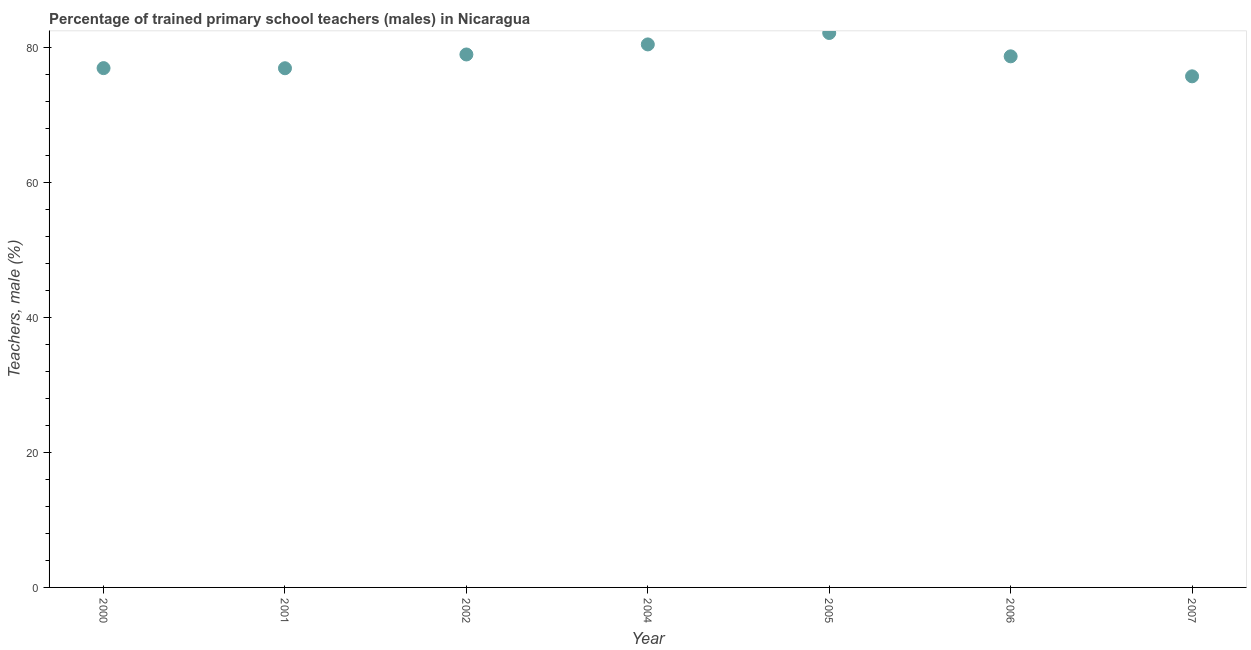What is the percentage of trained male teachers in 2007?
Offer a terse response. 75.78. Across all years, what is the maximum percentage of trained male teachers?
Your response must be concise. 82.21. Across all years, what is the minimum percentage of trained male teachers?
Provide a succinct answer. 75.78. In which year was the percentage of trained male teachers minimum?
Ensure brevity in your answer.  2007. What is the sum of the percentage of trained male teachers?
Offer a very short reply. 550.26. What is the difference between the percentage of trained male teachers in 2002 and 2007?
Offer a very short reply. 3.24. What is the average percentage of trained male teachers per year?
Ensure brevity in your answer.  78.61. What is the median percentage of trained male teachers?
Provide a succinct answer. 78.75. Do a majority of the years between 2000 and 2007 (inclusive) have percentage of trained male teachers greater than 56 %?
Your response must be concise. Yes. What is the ratio of the percentage of trained male teachers in 2000 to that in 2005?
Keep it short and to the point. 0.94. Is the percentage of trained male teachers in 2002 less than that in 2004?
Your response must be concise. Yes. Is the difference between the percentage of trained male teachers in 2000 and 2002 greater than the difference between any two years?
Keep it short and to the point. No. What is the difference between the highest and the second highest percentage of trained male teachers?
Your answer should be compact. 1.69. Is the sum of the percentage of trained male teachers in 2005 and 2007 greater than the maximum percentage of trained male teachers across all years?
Offer a terse response. Yes. What is the difference between the highest and the lowest percentage of trained male teachers?
Your answer should be very brief. 6.43. How many dotlines are there?
Provide a short and direct response. 1. What is the title of the graph?
Your answer should be very brief. Percentage of trained primary school teachers (males) in Nicaragua. What is the label or title of the X-axis?
Your answer should be compact. Year. What is the label or title of the Y-axis?
Your response must be concise. Teachers, male (%). What is the Teachers, male (%) in 2000?
Give a very brief answer. 77. What is the Teachers, male (%) in 2001?
Keep it short and to the point. 76.98. What is the Teachers, male (%) in 2002?
Your answer should be compact. 79.02. What is the Teachers, male (%) in 2004?
Provide a short and direct response. 80.51. What is the Teachers, male (%) in 2005?
Offer a very short reply. 82.21. What is the Teachers, male (%) in 2006?
Ensure brevity in your answer.  78.75. What is the Teachers, male (%) in 2007?
Your answer should be compact. 75.78. What is the difference between the Teachers, male (%) in 2000 and 2001?
Offer a very short reply. 0.02. What is the difference between the Teachers, male (%) in 2000 and 2002?
Your answer should be very brief. -2.02. What is the difference between the Teachers, male (%) in 2000 and 2004?
Offer a terse response. -3.51. What is the difference between the Teachers, male (%) in 2000 and 2005?
Provide a succinct answer. -5.21. What is the difference between the Teachers, male (%) in 2000 and 2006?
Make the answer very short. -1.75. What is the difference between the Teachers, male (%) in 2000 and 2007?
Your response must be concise. 1.22. What is the difference between the Teachers, male (%) in 2001 and 2002?
Your response must be concise. -2.04. What is the difference between the Teachers, male (%) in 2001 and 2004?
Your answer should be very brief. -3.53. What is the difference between the Teachers, male (%) in 2001 and 2005?
Your response must be concise. -5.23. What is the difference between the Teachers, male (%) in 2001 and 2006?
Offer a terse response. -1.77. What is the difference between the Teachers, male (%) in 2001 and 2007?
Provide a short and direct response. 1.2. What is the difference between the Teachers, male (%) in 2002 and 2004?
Ensure brevity in your answer.  -1.49. What is the difference between the Teachers, male (%) in 2002 and 2005?
Offer a terse response. -3.19. What is the difference between the Teachers, male (%) in 2002 and 2006?
Give a very brief answer. 0.28. What is the difference between the Teachers, male (%) in 2002 and 2007?
Your answer should be compact. 3.24. What is the difference between the Teachers, male (%) in 2004 and 2005?
Keep it short and to the point. -1.69. What is the difference between the Teachers, male (%) in 2004 and 2006?
Your answer should be compact. 1.77. What is the difference between the Teachers, male (%) in 2004 and 2007?
Your answer should be very brief. 4.73. What is the difference between the Teachers, male (%) in 2005 and 2006?
Provide a succinct answer. 3.46. What is the difference between the Teachers, male (%) in 2005 and 2007?
Keep it short and to the point. 6.43. What is the difference between the Teachers, male (%) in 2006 and 2007?
Ensure brevity in your answer.  2.96. What is the ratio of the Teachers, male (%) in 2000 to that in 2001?
Your response must be concise. 1. What is the ratio of the Teachers, male (%) in 2000 to that in 2004?
Offer a terse response. 0.96. What is the ratio of the Teachers, male (%) in 2000 to that in 2005?
Your response must be concise. 0.94. What is the ratio of the Teachers, male (%) in 2000 to that in 2006?
Your answer should be very brief. 0.98. What is the ratio of the Teachers, male (%) in 2000 to that in 2007?
Your response must be concise. 1.02. What is the ratio of the Teachers, male (%) in 2001 to that in 2002?
Make the answer very short. 0.97. What is the ratio of the Teachers, male (%) in 2001 to that in 2004?
Your answer should be compact. 0.96. What is the ratio of the Teachers, male (%) in 2001 to that in 2005?
Make the answer very short. 0.94. What is the ratio of the Teachers, male (%) in 2002 to that in 2004?
Your answer should be compact. 0.98. What is the ratio of the Teachers, male (%) in 2002 to that in 2006?
Provide a succinct answer. 1. What is the ratio of the Teachers, male (%) in 2002 to that in 2007?
Offer a very short reply. 1.04. What is the ratio of the Teachers, male (%) in 2004 to that in 2005?
Ensure brevity in your answer.  0.98. What is the ratio of the Teachers, male (%) in 2004 to that in 2007?
Your response must be concise. 1.06. What is the ratio of the Teachers, male (%) in 2005 to that in 2006?
Give a very brief answer. 1.04. What is the ratio of the Teachers, male (%) in 2005 to that in 2007?
Offer a very short reply. 1.08. What is the ratio of the Teachers, male (%) in 2006 to that in 2007?
Provide a succinct answer. 1.04. 